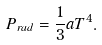Convert formula to latex. <formula><loc_0><loc_0><loc_500><loc_500>P _ { r a d } = \frac { 1 } { 3 } a T ^ { 4 } .</formula> 